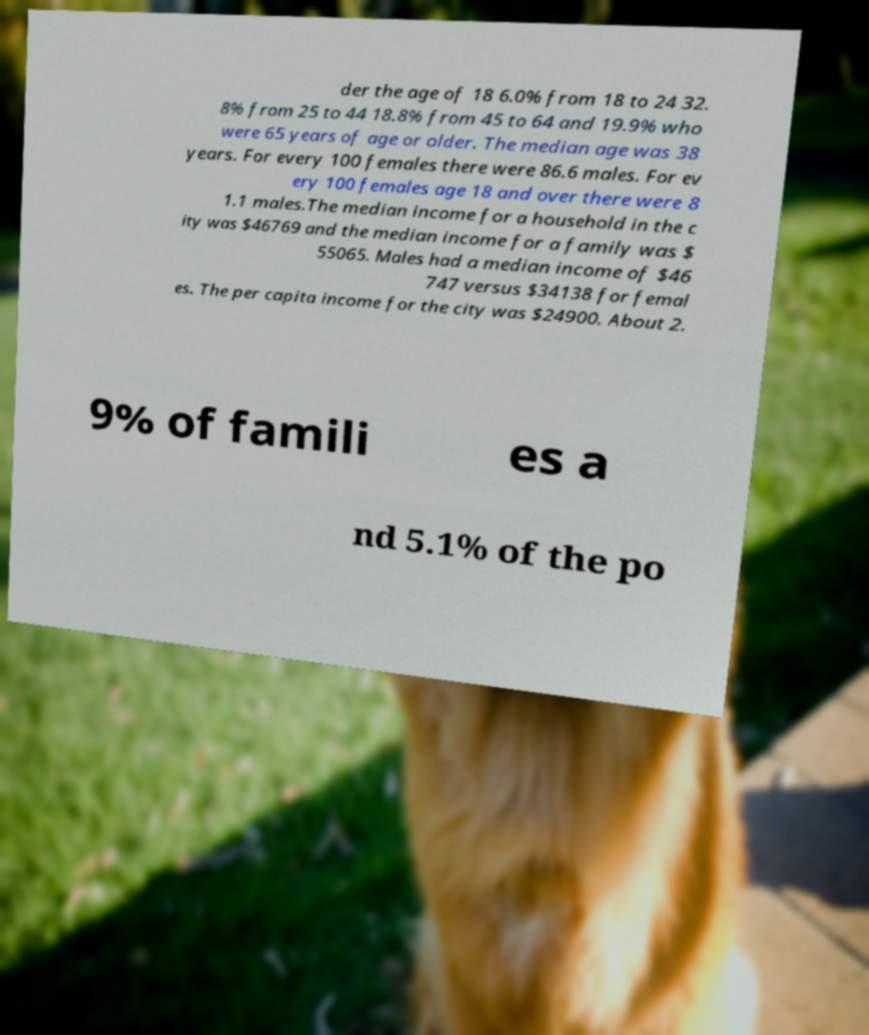What messages or text are displayed in this image? I need them in a readable, typed format. der the age of 18 6.0% from 18 to 24 32. 8% from 25 to 44 18.8% from 45 to 64 and 19.9% who were 65 years of age or older. The median age was 38 years. For every 100 females there were 86.6 males. For ev ery 100 females age 18 and over there were 8 1.1 males.The median income for a household in the c ity was $46769 and the median income for a family was $ 55065. Males had a median income of $46 747 versus $34138 for femal es. The per capita income for the city was $24900. About 2. 9% of famili es a nd 5.1% of the po 